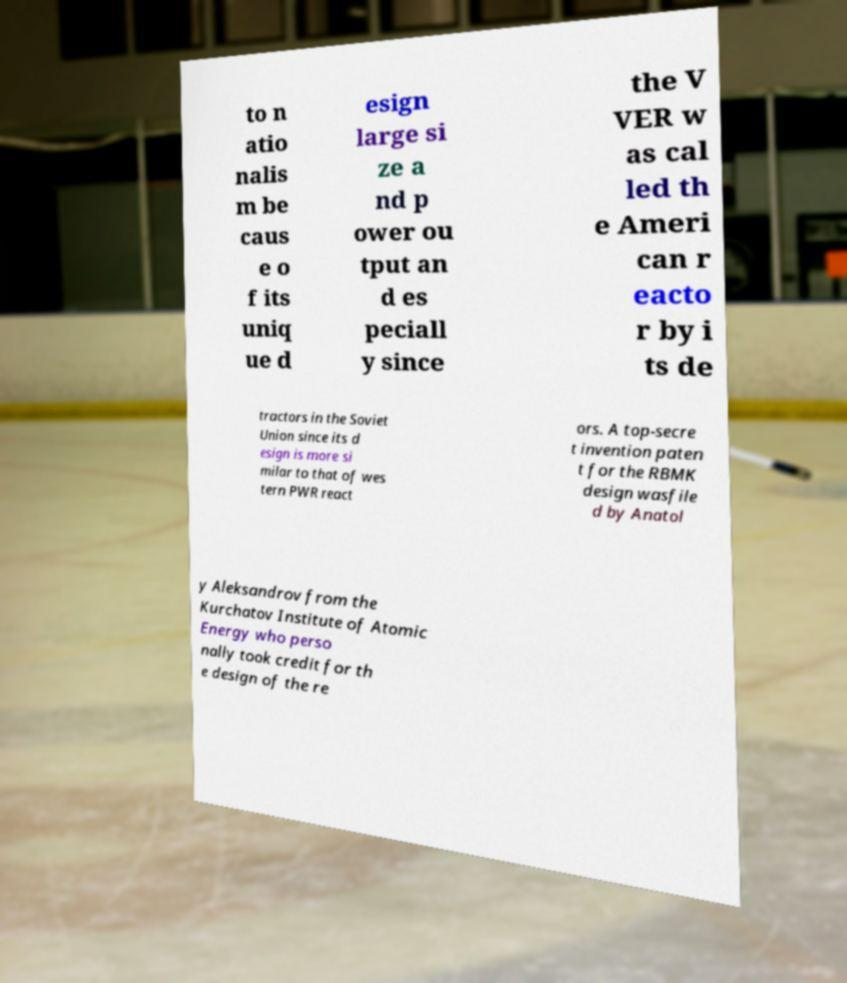Can you read and provide the text displayed in the image?This photo seems to have some interesting text. Can you extract and type it out for me? to n atio nalis m be caus e o f its uniq ue d esign large si ze a nd p ower ou tput an d es peciall y since the V VER w as cal led th e Ameri can r eacto r by i ts de tractors in the Soviet Union since its d esign is more si milar to that of wes tern PWR react ors. A top-secre t invention paten t for the RBMK design wasfile d by Anatol y Aleksandrov from the Kurchatov Institute of Atomic Energy who perso nally took credit for th e design of the re 